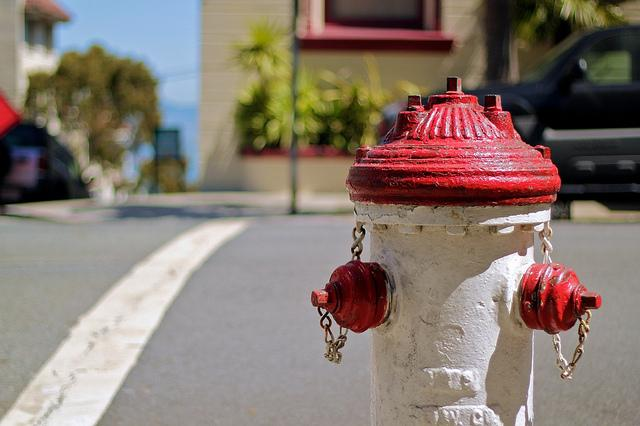What does the line near the hydrant signify?

Choices:
A) hopscotch boundary
B) road intersection
C) turn here
D) handicap parking road intersection 